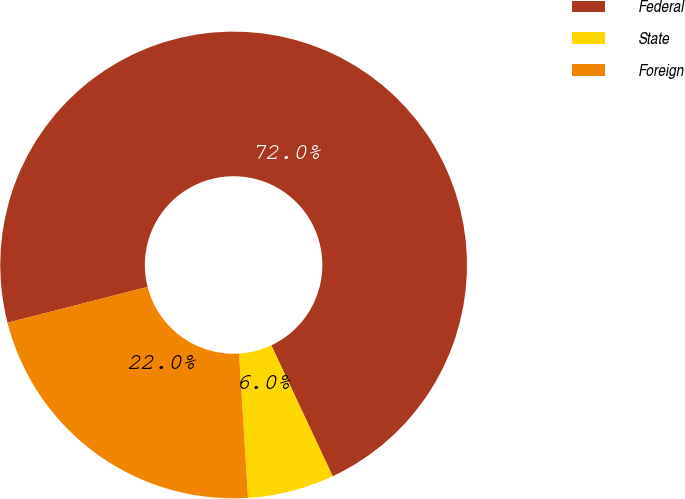Convert chart to OTSL. <chart><loc_0><loc_0><loc_500><loc_500><pie_chart><fcel>Federal<fcel>State<fcel>Foreign<nl><fcel>72.0%<fcel>6.0%<fcel>22.0%<nl></chart> 